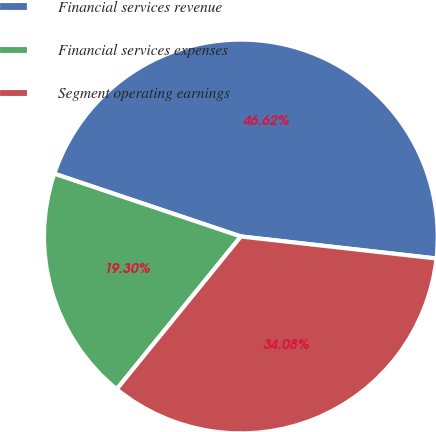Convert chart to OTSL. <chart><loc_0><loc_0><loc_500><loc_500><pie_chart><fcel>Financial services revenue<fcel>Financial services expenses<fcel>Segment operating earnings<nl><fcel>46.62%<fcel>19.3%<fcel>34.08%<nl></chart> 